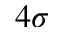Convert formula to latex. <formula><loc_0><loc_0><loc_500><loc_500>4 \sigma</formula> 